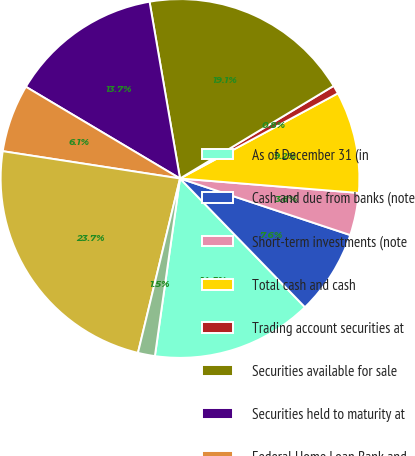<chart> <loc_0><loc_0><loc_500><loc_500><pie_chart><fcel>As of December 31 (in<fcel>Cash and due from banks (note<fcel>Short-term investments (note<fcel>Total cash and cash<fcel>Trading account securities at<fcel>Securities available for sale<fcel>Securities held to maturity at<fcel>Federal Home Loan Bank and<fcel>Total securities<fcel>Loans held for sale (note 5)<nl><fcel>14.5%<fcel>7.63%<fcel>3.82%<fcel>9.16%<fcel>0.76%<fcel>19.08%<fcel>13.74%<fcel>6.11%<fcel>23.66%<fcel>1.53%<nl></chart> 